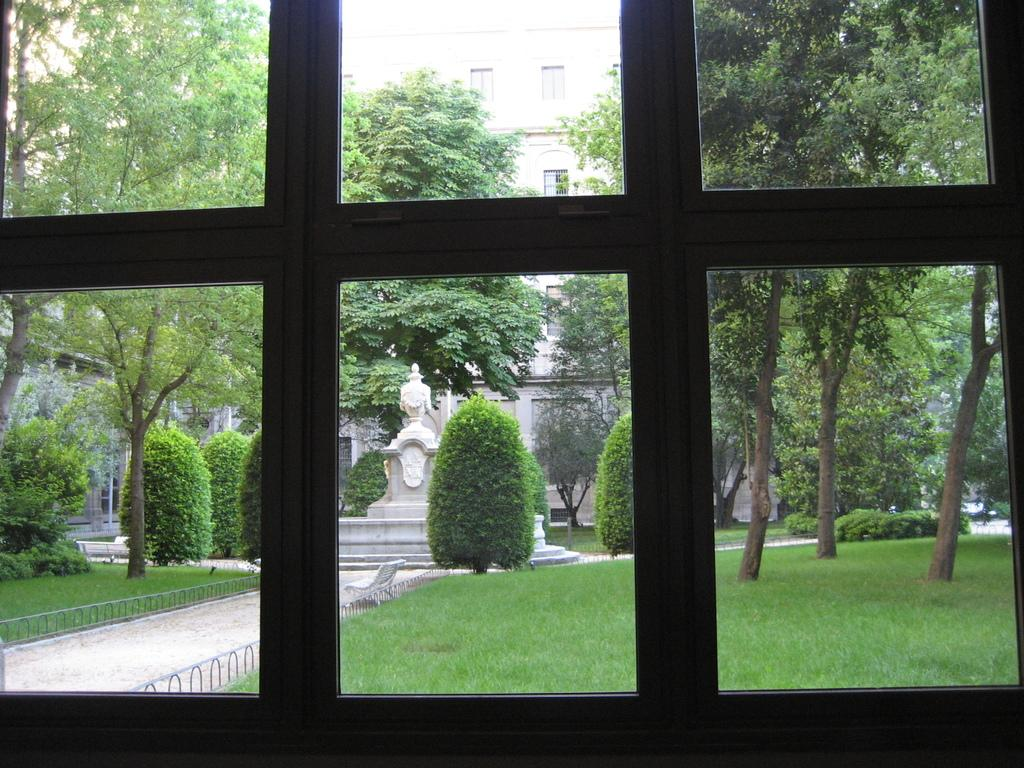What is located in the foreground of the image? There is a window in the foreground of the image. What can be seen through the window? Trees, buildings, plants, grass, a railing, a fountain, and a walkway are visible through the window. Can you describe the view through the window? The view through the window includes a mix of natural and man-made elements, such as trees, buildings, plants, grass, a railing, a fountain, and a walkway. What type of pets can be seen playing with the range in the image? There are no pets or ranges present in the image; it features a window with a view of various outdoor elements. 